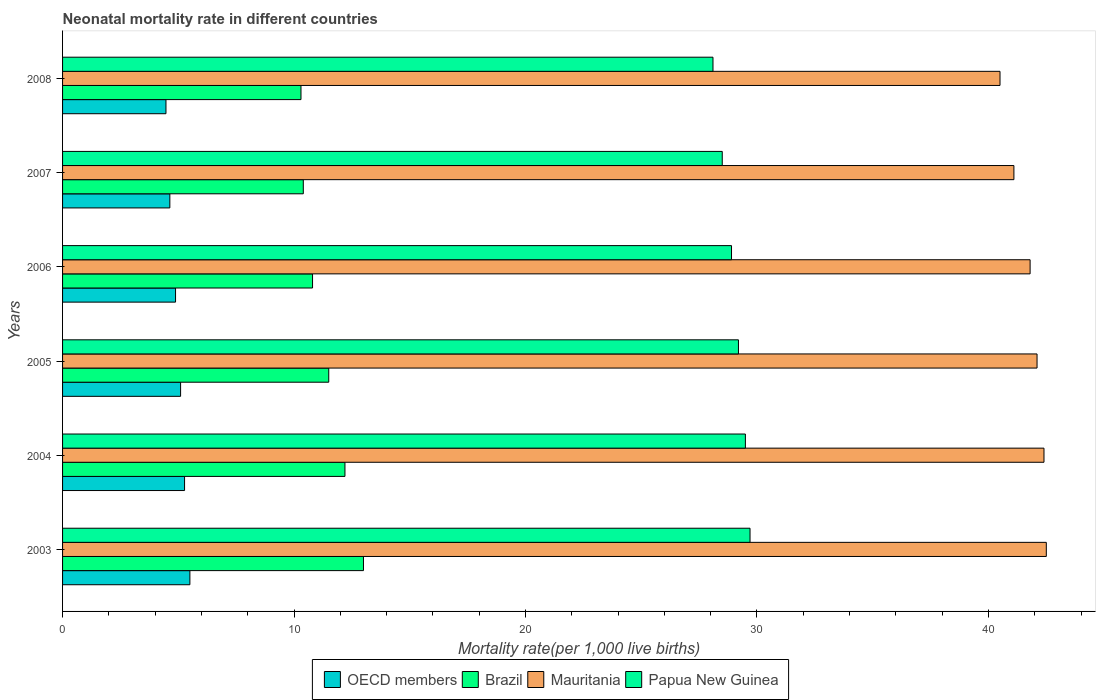Are the number of bars per tick equal to the number of legend labels?
Your answer should be very brief. Yes. Are the number of bars on each tick of the Y-axis equal?
Ensure brevity in your answer.  Yes. How many bars are there on the 3rd tick from the top?
Provide a succinct answer. 4. In how many cases, is the number of bars for a given year not equal to the number of legend labels?
Keep it short and to the point. 0. What is the neonatal mortality rate in Brazil in 2008?
Give a very brief answer. 10.3. Across all years, what is the maximum neonatal mortality rate in Papua New Guinea?
Ensure brevity in your answer.  29.7. Across all years, what is the minimum neonatal mortality rate in Papua New Guinea?
Give a very brief answer. 28.1. In which year was the neonatal mortality rate in Papua New Guinea minimum?
Make the answer very short. 2008. What is the total neonatal mortality rate in Papua New Guinea in the graph?
Your answer should be compact. 173.9. What is the difference between the neonatal mortality rate in OECD members in 2003 and that in 2008?
Your answer should be compact. 1.03. What is the difference between the neonatal mortality rate in OECD members in 2006 and the neonatal mortality rate in Brazil in 2005?
Make the answer very short. -6.62. What is the average neonatal mortality rate in OECD members per year?
Your answer should be compact. 4.98. In the year 2007, what is the difference between the neonatal mortality rate in Brazil and neonatal mortality rate in Papua New Guinea?
Give a very brief answer. -18.1. In how many years, is the neonatal mortality rate in Mauritania greater than 14 ?
Keep it short and to the point. 6. What is the ratio of the neonatal mortality rate in OECD members in 2003 to that in 2004?
Provide a succinct answer. 1.04. Is the neonatal mortality rate in Brazil in 2003 less than that in 2007?
Your answer should be very brief. No. What is the difference between the highest and the second highest neonatal mortality rate in Papua New Guinea?
Your response must be concise. 0.2. Is it the case that in every year, the sum of the neonatal mortality rate in OECD members and neonatal mortality rate in Mauritania is greater than the sum of neonatal mortality rate in Brazil and neonatal mortality rate in Papua New Guinea?
Provide a succinct answer. No. What does the 3rd bar from the bottom in 2004 represents?
Provide a short and direct response. Mauritania. What is the difference between two consecutive major ticks on the X-axis?
Your answer should be compact. 10. Are the values on the major ticks of X-axis written in scientific E-notation?
Your answer should be compact. No. Does the graph contain any zero values?
Offer a very short reply. No. Where does the legend appear in the graph?
Offer a terse response. Bottom center. How are the legend labels stacked?
Offer a terse response. Horizontal. What is the title of the graph?
Keep it short and to the point. Neonatal mortality rate in different countries. Does "Somalia" appear as one of the legend labels in the graph?
Offer a very short reply. No. What is the label or title of the X-axis?
Provide a short and direct response. Mortality rate(per 1,0 live births). What is the label or title of the Y-axis?
Make the answer very short. Years. What is the Mortality rate(per 1,000 live births) in OECD members in 2003?
Your answer should be compact. 5.5. What is the Mortality rate(per 1,000 live births) in Mauritania in 2003?
Offer a terse response. 42.5. What is the Mortality rate(per 1,000 live births) in Papua New Guinea in 2003?
Offer a terse response. 29.7. What is the Mortality rate(per 1,000 live births) in OECD members in 2004?
Offer a very short reply. 5.27. What is the Mortality rate(per 1,000 live births) of Brazil in 2004?
Ensure brevity in your answer.  12.2. What is the Mortality rate(per 1,000 live births) of Mauritania in 2004?
Your response must be concise. 42.4. What is the Mortality rate(per 1,000 live births) of Papua New Guinea in 2004?
Your response must be concise. 29.5. What is the Mortality rate(per 1,000 live births) in OECD members in 2005?
Ensure brevity in your answer.  5.1. What is the Mortality rate(per 1,000 live births) of Mauritania in 2005?
Ensure brevity in your answer.  42.1. What is the Mortality rate(per 1,000 live births) of Papua New Guinea in 2005?
Offer a terse response. 29.2. What is the Mortality rate(per 1,000 live births) in OECD members in 2006?
Provide a short and direct response. 4.88. What is the Mortality rate(per 1,000 live births) in Mauritania in 2006?
Your answer should be very brief. 41.8. What is the Mortality rate(per 1,000 live births) in Papua New Guinea in 2006?
Ensure brevity in your answer.  28.9. What is the Mortality rate(per 1,000 live births) of OECD members in 2007?
Your answer should be very brief. 4.63. What is the Mortality rate(per 1,000 live births) in Brazil in 2007?
Keep it short and to the point. 10.4. What is the Mortality rate(per 1,000 live births) of Mauritania in 2007?
Your answer should be very brief. 41.1. What is the Mortality rate(per 1,000 live births) of Papua New Guinea in 2007?
Make the answer very short. 28.5. What is the Mortality rate(per 1,000 live births) in OECD members in 2008?
Keep it short and to the point. 4.47. What is the Mortality rate(per 1,000 live births) of Mauritania in 2008?
Make the answer very short. 40.5. What is the Mortality rate(per 1,000 live births) of Papua New Guinea in 2008?
Provide a short and direct response. 28.1. Across all years, what is the maximum Mortality rate(per 1,000 live births) of OECD members?
Give a very brief answer. 5.5. Across all years, what is the maximum Mortality rate(per 1,000 live births) of Mauritania?
Your answer should be compact. 42.5. Across all years, what is the maximum Mortality rate(per 1,000 live births) in Papua New Guinea?
Ensure brevity in your answer.  29.7. Across all years, what is the minimum Mortality rate(per 1,000 live births) in OECD members?
Your response must be concise. 4.47. Across all years, what is the minimum Mortality rate(per 1,000 live births) in Mauritania?
Ensure brevity in your answer.  40.5. Across all years, what is the minimum Mortality rate(per 1,000 live births) in Papua New Guinea?
Offer a very short reply. 28.1. What is the total Mortality rate(per 1,000 live births) of OECD members in the graph?
Your answer should be very brief. 29.85. What is the total Mortality rate(per 1,000 live births) of Brazil in the graph?
Provide a succinct answer. 68.2. What is the total Mortality rate(per 1,000 live births) in Mauritania in the graph?
Your answer should be compact. 250.4. What is the total Mortality rate(per 1,000 live births) in Papua New Guinea in the graph?
Ensure brevity in your answer.  173.9. What is the difference between the Mortality rate(per 1,000 live births) in OECD members in 2003 and that in 2004?
Provide a succinct answer. 0.23. What is the difference between the Mortality rate(per 1,000 live births) in Mauritania in 2003 and that in 2004?
Your answer should be compact. 0.1. What is the difference between the Mortality rate(per 1,000 live births) of OECD members in 2003 and that in 2005?
Your response must be concise. 0.4. What is the difference between the Mortality rate(per 1,000 live births) of OECD members in 2003 and that in 2006?
Keep it short and to the point. 0.62. What is the difference between the Mortality rate(per 1,000 live births) in Brazil in 2003 and that in 2006?
Offer a terse response. 2.2. What is the difference between the Mortality rate(per 1,000 live births) of Mauritania in 2003 and that in 2006?
Give a very brief answer. 0.7. What is the difference between the Mortality rate(per 1,000 live births) of OECD members in 2003 and that in 2007?
Your response must be concise. 0.87. What is the difference between the Mortality rate(per 1,000 live births) of OECD members in 2003 and that in 2008?
Provide a succinct answer. 1.03. What is the difference between the Mortality rate(per 1,000 live births) of Mauritania in 2003 and that in 2008?
Keep it short and to the point. 2. What is the difference between the Mortality rate(per 1,000 live births) of Papua New Guinea in 2003 and that in 2008?
Provide a short and direct response. 1.6. What is the difference between the Mortality rate(per 1,000 live births) of OECD members in 2004 and that in 2005?
Provide a succinct answer. 0.17. What is the difference between the Mortality rate(per 1,000 live births) in Brazil in 2004 and that in 2005?
Provide a short and direct response. 0.7. What is the difference between the Mortality rate(per 1,000 live births) of Mauritania in 2004 and that in 2005?
Provide a short and direct response. 0.3. What is the difference between the Mortality rate(per 1,000 live births) in OECD members in 2004 and that in 2006?
Provide a succinct answer. 0.39. What is the difference between the Mortality rate(per 1,000 live births) of Brazil in 2004 and that in 2006?
Keep it short and to the point. 1.4. What is the difference between the Mortality rate(per 1,000 live births) of OECD members in 2004 and that in 2007?
Your answer should be compact. 0.64. What is the difference between the Mortality rate(per 1,000 live births) in Brazil in 2004 and that in 2007?
Your answer should be compact. 1.8. What is the difference between the Mortality rate(per 1,000 live births) in Papua New Guinea in 2004 and that in 2007?
Your answer should be very brief. 1. What is the difference between the Mortality rate(per 1,000 live births) of OECD members in 2004 and that in 2008?
Your response must be concise. 0.8. What is the difference between the Mortality rate(per 1,000 live births) of OECD members in 2005 and that in 2006?
Ensure brevity in your answer.  0.22. What is the difference between the Mortality rate(per 1,000 live births) of Brazil in 2005 and that in 2006?
Give a very brief answer. 0.7. What is the difference between the Mortality rate(per 1,000 live births) of OECD members in 2005 and that in 2007?
Your answer should be compact. 0.46. What is the difference between the Mortality rate(per 1,000 live births) of Brazil in 2005 and that in 2007?
Your response must be concise. 1.1. What is the difference between the Mortality rate(per 1,000 live births) in Mauritania in 2005 and that in 2007?
Offer a very short reply. 1. What is the difference between the Mortality rate(per 1,000 live births) of Papua New Guinea in 2005 and that in 2007?
Offer a terse response. 0.7. What is the difference between the Mortality rate(per 1,000 live births) of OECD members in 2005 and that in 2008?
Give a very brief answer. 0.63. What is the difference between the Mortality rate(per 1,000 live births) in Brazil in 2005 and that in 2008?
Ensure brevity in your answer.  1.2. What is the difference between the Mortality rate(per 1,000 live births) of Mauritania in 2005 and that in 2008?
Offer a terse response. 1.6. What is the difference between the Mortality rate(per 1,000 live births) of OECD members in 2006 and that in 2007?
Your response must be concise. 0.25. What is the difference between the Mortality rate(per 1,000 live births) of Mauritania in 2006 and that in 2007?
Provide a short and direct response. 0.7. What is the difference between the Mortality rate(per 1,000 live births) in OECD members in 2006 and that in 2008?
Keep it short and to the point. 0.41. What is the difference between the Mortality rate(per 1,000 live births) of Mauritania in 2006 and that in 2008?
Make the answer very short. 1.3. What is the difference between the Mortality rate(per 1,000 live births) in OECD members in 2007 and that in 2008?
Give a very brief answer. 0.17. What is the difference between the Mortality rate(per 1,000 live births) of Mauritania in 2007 and that in 2008?
Your response must be concise. 0.6. What is the difference between the Mortality rate(per 1,000 live births) in OECD members in 2003 and the Mortality rate(per 1,000 live births) in Brazil in 2004?
Provide a succinct answer. -6.7. What is the difference between the Mortality rate(per 1,000 live births) of OECD members in 2003 and the Mortality rate(per 1,000 live births) of Mauritania in 2004?
Your response must be concise. -36.9. What is the difference between the Mortality rate(per 1,000 live births) in OECD members in 2003 and the Mortality rate(per 1,000 live births) in Papua New Guinea in 2004?
Provide a short and direct response. -24. What is the difference between the Mortality rate(per 1,000 live births) in Brazil in 2003 and the Mortality rate(per 1,000 live births) in Mauritania in 2004?
Give a very brief answer. -29.4. What is the difference between the Mortality rate(per 1,000 live births) in Brazil in 2003 and the Mortality rate(per 1,000 live births) in Papua New Guinea in 2004?
Your answer should be very brief. -16.5. What is the difference between the Mortality rate(per 1,000 live births) of OECD members in 2003 and the Mortality rate(per 1,000 live births) of Brazil in 2005?
Make the answer very short. -6. What is the difference between the Mortality rate(per 1,000 live births) in OECD members in 2003 and the Mortality rate(per 1,000 live births) in Mauritania in 2005?
Make the answer very short. -36.6. What is the difference between the Mortality rate(per 1,000 live births) in OECD members in 2003 and the Mortality rate(per 1,000 live births) in Papua New Guinea in 2005?
Provide a short and direct response. -23.7. What is the difference between the Mortality rate(per 1,000 live births) in Brazil in 2003 and the Mortality rate(per 1,000 live births) in Mauritania in 2005?
Offer a terse response. -29.1. What is the difference between the Mortality rate(per 1,000 live births) of Brazil in 2003 and the Mortality rate(per 1,000 live births) of Papua New Guinea in 2005?
Give a very brief answer. -16.2. What is the difference between the Mortality rate(per 1,000 live births) in OECD members in 2003 and the Mortality rate(per 1,000 live births) in Brazil in 2006?
Make the answer very short. -5.3. What is the difference between the Mortality rate(per 1,000 live births) in OECD members in 2003 and the Mortality rate(per 1,000 live births) in Mauritania in 2006?
Provide a succinct answer. -36.3. What is the difference between the Mortality rate(per 1,000 live births) of OECD members in 2003 and the Mortality rate(per 1,000 live births) of Papua New Guinea in 2006?
Keep it short and to the point. -23.4. What is the difference between the Mortality rate(per 1,000 live births) of Brazil in 2003 and the Mortality rate(per 1,000 live births) of Mauritania in 2006?
Your response must be concise. -28.8. What is the difference between the Mortality rate(per 1,000 live births) in Brazil in 2003 and the Mortality rate(per 1,000 live births) in Papua New Guinea in 2006?
Keep it short and to the point. -15.9. What is the difference between the Mortality rate(per 1,000 live births) in OECD members in 2003 and the Mortality rate(per 1,000 live births) in Brazil in 2007?
Offer a terse response. -4.9. What is the difference between the Mortality rate(per 1,000 live births) of OECD members in 2003 and the Mortality rate(per 1,000 live births) of Mauritania in 2007?
Your answer should be compact. -35.6. What is the difference between the Mortality rate(per 1,000 live births) in OECD members in 2003 and the Mortality rate(per 1,000 live births) in Papua New Guinea in 2007?
Keep it short and to the point. -23. What is the difference between the Mortality rate(per 1,000 live births) in Brazil in 2003 and the Mortality rate(per 1,000 live births) in Mauritania in 2007?
Keep it short and to the point. -28.1. What is the difference between the Mortality rate(per 1,000 live births) of Brazil in 2003 and the Mortality rate(per 1,000 live births) of Papua New Guinea in 2007?
Keep it short and to the point. -15.5. What is the difference between the Mortality rate(per 1,000 live births) of OECD members in 2003 and the Mortality rate(per 1,000 live births) of Brazil in 2008?
Your answer should be very brief. -4.8. What is the difference between the Mortality rate(per 1,000 live births) of OECD members in 2003 and the Mortality rate(per 1,000 live births) of Mauritania in 2008?
Offer a very short reply. -35. What is the difference between the Mortality rate(per 1,000 live births) in OECD members in 2003 and the Mortality rate(per 1,000 live births) in Papua New Guinea in 2008?
Ensure brevity in your answer.  -22.6. What is the difference between the Mortality rate(per 1,000 live births) of Brazil in 2003 and the Mortality rate(per 1,000 live births) of Mauritania in 2008?
Offer a very short reply. -27.5. What is the difference between the Mortality rate(per 1,000 live births) of Brazil in 2003 and the Mortality rate(per 1,000 live births) of Papua New Guinea in 2008?
Provide a short and direct response. -15.1. What is the difference between the Mortality rate(per 1,000 live births) in OECD members in 2004 and the Mortality rate(per 1,000 live births) in Brazil in 2005?
Your answer should be compact. -6.23. What is the difference between the Mortality rate(per 1,000 live births) of OECD members in 2004 and the Mortality rate(per 1,000 live births) of Mauritania in 2005?
Give a very brief answer. -36.83. What is the difference between the Mortality rate(per 1,000 live births) of OECD members in 2004 and the Mortality rate(per 1,000 live births) of Papua New Guinea in 2005?
Offer a terse response. -23.93. What is the difference between the Mortality rate(per 1,000 live births) in Brazil in 2004 and the Mortality rate(per 1,000 live births) in Mauritania in 2005?
Your response must be concise. -29.9. What is the difference between the Mortality rate(per 1,000 live births) in Brazil in 2004 and the Mortality rate(per 1,000 live births) in Papua New Guinea in 2005?
Give a very brief answer. -17. What is the difference between the Mortality rate(per 1,000 live births) in Mauritania in 2004 and the Mortality rate(per 1,000 live births) in Papua New Guinea in 2005?
Offer a very short reply. 13.2. What is the difference between the Mortality rate(per 1,000 live births) of OECD members in 2004 and the Mortality rate(per 1,000 live births) of Brazil in 2006?
Provide a succinct answer. -5.53. What is the difference between the Mortality rate(per 1,000 live births) in OECD members in 2004 and the Mortality rate(per 1,000 live births) in Mauritania in 2006?
Make the answer very short. -36.53. What is the difference between the Mortality rate(per 1,000 live births) of OECD members in 2004 and the Mortality rate(per 1,000 live births) of Papua New Guinea in 2006?
Offer a very short reply. -23.63. What is the difference between the Mortality rate(per 1,000 live births) in Brazil in 2004 and the Mortality rate(per 1,000 live births) in Mauritania in 2006?
Keep it short and to the point. -29.6. What is the difference between the Mortality rate(per 1,000 live births) of Brazil in 2004 and the Mortality rate(per 1,000 live births) of Papua New Guinea in 2006?
Your response must be concise. -16.7. What is the difference between the Mortality rate(per 1,000 live births) in Mauritania in 2004 and the Mortality rate(per 1,000 live births) in Papua New Guinea in 2006?
Your response must be concise. 13.5. What is the difference between the Mortality rate(per 1,000 live births) in OECD members in 2004 and the Mortality rate(per 1,000 live births) in Brazil in 2007?
Offer a terse response. -5.13. What is the difference between the Mortality rate(per 1,000 live births) of OECD members in 2004 and the Mortality rate(per 1,000 live births) of Mauritania in 2007?
Your answer should be compact. -35.83. What is the difference between the Mortality rate(per 1,000 live births) in OECD members in 2004 and the Mortality rate(per 1,000 live births) in Papua New Guinea in 2007?
Keep it short and to the point. -23.23. What is the difference between the Mortality rate(per 1,000 live births) in Brazil in 2004 and the Mortality rate(per 1,000 live births) in Mauritania in 2007?
Provide a short and direct response. -28.9. What is the difference between the Mortality rate(per 1,000 live births) in Brazil in 2004 and the Mortality rate(per 1,000 live births) in Papua New Guinea in 2007?
Your answer should be compact. -16.3. What is the difference between the Mortality rate(per 1,000 live births) in Mauritania in 2004 and the Mortality rate(per 1,000 live births) in Papua New Guinea in 2007?
Ensure brevity in your answer.  13.9. What is the difference between the Mortality rate(per 1,000 live births) of OECD members in 2004 and the Mortality rate(per 1,000 live births) of Brazil in 2008?
Provide a succinct answer. -5.03. What is the difference between the Mortality rate(per 1,000 live births) of OECD members in 2004 and the Mortality rate(per 1,000 live births) of Mauritania in 2008?
Offer a terse response. -35.23. What is the difference between the Mortality rate(per 1,000 live births) in OECD members in 2004 and the Mortality rate(per 1,000 live births) in Papua New Guinea in 2008?
Keep it short and to the point. -22.83. What is the difference between the Mortality rate(per 1,000 live births) of Brazil in 2004 and the Mortality rate(per 1,000 live births) of Mauritania in 2008?
Give a very brief answer. -28.3. What is the difference between the Mortality rate(per 1,000 live births) of Brazil in 2004 and the Mortality rate(per 1,000 live births) of Papua New Guinea in 2008?
Offer a very short reply. -15.9. What is the difference between the Mortality rate(per 1,000 live births) in Mauritania in 2004 and the Mortality rate(per 1,000 live births) in Papua New Guinea in 2008?
Provide a succinct answer. 14.3. What is the difference between the Mortality rate(per 1,000 live births) in OECD members in 2005 and the Mortality rate(per 1,000 live births) in Brazil in 2006?
Your response must be concise. -5.7. What is the difference between the Mortality rate(per 1,000 live births) of OECD members in 2005 and the Mortality rate(per 1,000 live births) of Mauritania in 2006?
Provide a short and direct response. -36.7. What is the difference between the Mortality rate(per 1,000 live births) in OECD members in 2005 and the Mortality rate(per 1,000 live births) in Papua New Guinea in 2006?
Your answer should be compact. -23.8. What is the difference between the Mortality rate(per 1,000 live births) in Brazil in 2005 and the Mortality rate(per 1,000 live births) in Mauritania in 2006?
Your response must be concise. -30.3. What is the difference between the Mortality rate(per 1,000 live births) of Brazil in 2005 and the Mortality rate(per 1,000 live births) of Papua New Guinea in 2006?
Offer a very short reply. -17.4. What is the difference between the Mortality rate(per 1,000 live births) in Mauritania in 2005 and the Mortality rate(per 1,000 live births) in Papua New Guinea in 2006?
Ensure brevity in your answer.  13.2. What is the difference between the Mortality rate(per 1,000 live births) of OECD members in 2005 and the Mortality rate(per 1,000 live births) of Brazil in 2007?
Make the answer very short. -5.3. What is the difference between the Mortality rate(per 1,000 live births) of OECD members in 2005 and the Mortality rate(per 1,000 live births) of Mauritania in 2007?
Offer a terse response. -36. What is the difference between the Mortality rate(per 1,000 live births) in OECD members in 2005 and the Mortality rate(per 1,000 live births) in Papua New Guinea in 2007?
Your response must be concise. -23.4. What is the difference between the Mortality rate(per 1,000 live births) in Brazil in 2005 and the Mortality rate(per 1,000 live births) in Mauritania in 2007?
Your answer should be compact. -29.6. What is the difference between the Mortality rate(per 1,000 live births) in Brazil in 2005 and the Mortality rate(per 1,000 live births) in Papua New Guinea in 2007?
Give a very brief answer. -17. What is the difference between the Mortality rate(per 1,000 live births) of Mauritania in 2005 and the Mortality rate(per 1,000 live births) of Papua New Guinea in 2007?
Provide a succinct answer. 13.6. What is the difference between the Mortality rate(per 1,000 live births) of OECD members in 2005 and the Mortality rate(per 1,000 live births) of Brazil in 2008?
Make the answer very short. -5.2. What is the difference between the Mortality rate(per 1,000 live births) of OECD members in 2005 and the Mortality rate(per 1,000 live births) of Mauritania in 2008?
Ensure brevity in your answer.  -35.4. What is the difference between the Mortality rate(per 1,000 live births) of OECD members in 2005 and the Mortality rate(per 1,000 live births) of Papua New Guinea in 2008?
Your answer should be very brief. -23. What is the difference between the Mortality rate(per 1,000 live births) of Brazil in 2005 and the Mortality rate(per 1,000 live births) of Papua New Guinea in 2008?
Provide a succinct answer. -16.6. What is the difference between the Mortality rate(per 1,000 live births) in OECD members in 2006 and the Mortality rate(per 1,000 live births) in Brazil in 2007?
Make the answer very short. -5.52. What is the difference between the Mortality rate(per 1,000 live births) in OECD members in 2006 and the Mortality rate(per 1,000 live births) in Mauritania in 2007?
Offer a terse response. -36.22. What is the difference between the Mortality rate(per 1,000 live births) in OECD members in 2006 and the Mortality rate(per 1,000 live births) in Papua New Guinea in 2007?
Offer a terse response. -23.62. What is the difference between the Mortality rate(per 1,000 live births) of Brazil in 2006 and the Mortality rate(per 1,000 live births) of Mauritania in 2007?
Make the answer very short. -30.3. What is the difference between the Mortality rate(per 1,000 live births) of Brazil in 2006 and the Mortality rate(per 1,000 live births) of Papua New Guinea in 2007?
Your answer should be very brief. -17.7. What is the difference between the Mortality rate(per 1,000 live births) of OECD members in 2006 and the Mortality rate(per 1,000 live births) of Brazil in 2008?
Offer a terse response. -5.42. What is the difference between the Mortality rate(per 1,000 live births) in OECD members in 2006 and the Mortality rate(per 1,000 live births) in Mauritania in 2008?
Offer a terse response. -35.62. What is the difference between the Mortality rate(per 1,000 live births) in OECD members in 2006 and the Mortality rate(per 1,000 live births) in Papua New Guinea in 2008?
Provide a short and direct response. -23.22. What is the difference between the Mortality rate(per 1,000 live births) in Brazil in 2006 and the Mortality rate(per 1,000 live births) in Mauritania in 2008?
Keep it short and to the point. -29.7. What is the difference between the Mortality rate(per 1,000 live births) of Brazil in 2006 and the Mortality rate(per 1,000 live births) of Papua New Guinea in 2008?
Provide a succinct answer. -17.3. What is the difference between the Mortality rate(per 1,000 live births) of Mauritania in 2006 and the Mortality rate(per 1,000 live births) of Papua New Guinea in 2008?
Offer a terse response. 13.7. What is the difference between the Mortality rate(per 1,000 live births) in OECD members in 2007 and the Mortality rate(per 1,000 live births) in Brazil in 2008?
Keep it short and to the point. -5.67. What is the difference between the Mortality rate(per 1,000 live births) of OECD members in 2007 and the Mortality rate(per 1,000 live births) of Mauritania in 2008?
Offer a very short reply. -35.87. What is the difference between the Mortality rate(per 1,000 live births) of OECD members in 2007 and the Mortality rate(per 1,000 live births) of Papua New Guinea in 2008?
Your response must be concise. -23.47. What is the difference between the Mortality rate(per 1,000 live births) of Brazil in 2007 and the Mortality rate(per 1,000 live births) of Mauritania in 2008?
Provide a succinct answer. -30.1. What is the difference between the Mortality rate(per 1,000 live births) in Brazil in 2007 and the Mortality rate(per 1,000 live births) in Papua New Guinea in 2008?
Keep it short and to the point. -17.7. What is the average Mortality rate(per 1,000 live births) of OECD members per year?
Ensure brevity in your answer.  4.98. What is the average Mortality rate(per 1,000 live births) of Brazil per year?
Give a very brief answer. 11.37. What is the average Mortality rate(per 1,000 live births) in Mauritania per year?
Provide a short and direct response. 41.73. What is the average Mortality rate(per 1,000 live births) in Papua New Guinea per year?
Ensure brevity in your answer.  28.98. In the year 2003, what is the difference between the Mortality rate(per 1,000 live births) of OECD members and Mortality rate(per 1,000 live births) of Brazil?
Give a very brief answer. -7.5. In the year 2003, what is the difference between the Mortality rate(per 1,000 live births) of OECD members and Mortality rate(per 1,000 live births) of Mauritania?
Keep it short and to the point. -37. In the year 2003, what is the difference between the Mortality rate(per 1,000 live births) in OECD members and Mortality rate(per 1,000 live births) in Papua New Guinea?
Provide a short and direct response. -24.2. In the year 2003, what is the difference between the Mortality rate(per 1,000 live births) in Brazil and Mortality rate(per 1,000 live births) in Mauritania?
Ensure brevity in your answer.  -29.5. In the year 2003, what is the difference between the Mortality rate(per 1,000 live births) of Brazil and Mortality rate(per 1,000 live births) of Papua New Guinea?
Offer a terse response. -16.7. In the year 2003, what is the difference between the Mortality rate(per 1,000 live births) of Mauritania and Mortality rate(per 1,000 live births) of Papua New Guinea?
Your answer should be compact. 12.8. In the year 2004, what is the difference between the Mortality rate(per 1,000 live births) of OECD members and Mortality rate(per 1,000 live births) of Brazil?
Give a very brief answer. -6.93. In the year 2004, what is the difference between the Mortality rate(per 1,000 live births) in OECD members and Mortality rate(per 1,000 live births) in Mauritania?
Offer a terse response. -37.13. In the year 2004, what is the difference between the Mortality rate(per 1,000 live births) of OECD members and Mortality rate(per 1,000 live births) of Papua New Guinea?
Your answer should be very brief. -24.23. In the year 2004, what is the difference between the Mortality rate(per 1,000 live births) of Brazil and Mortality rate(per 1,000 live births) of Mauritania?
Your response must be concise. -30.2. In the year 2004, what is the difference between the Mortality rate(per 1,000 live births) of Brazil and Mortality rate(per 1,000 live births) of Papua New Guinea?
Make the answer very short. -17.3. In the year 2005, what is the difference between the Mortality rate(per 1,000 live births) in OECD members and Mortality rate(per 1,000 live births) in Brazil?
Offer a very short reply. -6.4. In the year 2005, what is the difference between the Mortality rate(per 1,000 live births) in OECD members and Mortality rate(per 1,000 live births) in Mauritania?
Provide a short and direct response. -37. In the year 2005, what is the difference between the Mortality rate(per 1,000 live births) in OECD members and Mortality rate(per 1,000 live births) in Papua New Guinea?
Offer a terse response. -24.1. In the year 2005, what is the difference between the Mortality rate(per 1,000 live births) in Brazil and Mortality rate(per 1,000 live births) in Mauritania?
Provide a succinct answer. -30.6. In the year 2005, what is the difference between the Mortality rate(per 1,000 live births) of Brazil and Mortality rate(per 1,000 live births) of Papua New Guinea?
Your response must be concise. -17.7. In the year 2005, what is the difference between the Mortality rate(per 1,000 live births) in Mauritania and Mortality rate(per 1,000 live births) in Papua New Guinea?
Give a very brief answer. 12.9. In the year 2006, what is the difference between the Mortality rate(per 1,000 live births) of OECD members and Mortality rate(per 1,000 live births) of Brazil?
Provide a succinct answer. -5.92. In the year 2006, what is the difference between the Mortality rate(per 1,000 live births) of OECD members and Mortality rate(per 1,000 live births) of Mauritania?
Offer a terse response. -36.92. In the year 2006, what is the difference between the Mortality rate(per 1,000 live births) in OECD members and Mortality rate(per 1,000 live births) in Papua New Guinea?
Provide a short and direct response. -24.02. In the year 2006, what is the difference between the Mortality rate(per 1,000 live births) of Brazil and Mortality rate(per 1,000 live births) of Mauritania?
Provide a short and direct response. -31. In the year 2006, what is the difference between the Mortality rate(per 1,000 live births) in Brazil and Mortality rate(per 1,000 live births) in Papua New Guinea?
Keep it short and to the point. -18.1. In the year 2007, what is the difference between the Mortality rate(per 1,000 live births) of OECD members and Mortality rate(per 1,000 live births) of Brazil?
Your answer should be compact. -5.77. In the year 2007, what is the difference between the Mortality rate(per 1,000 live births) of OECD members and Mortality rate(per 1,000 live births) of Mauritania?
Provide a short and direct response. -36.47. In the year 2007, what is the difference between the Mortality rate(per 1,000 live births) of OECD members and Mortality rate(per 1,000 live births) of Papua New Guinea?
Your answer should be compact. -23.87. In the year 2007, what is the difference between the Mortality rate(per 1,000 live births) of Brazil and Mortality rate(per 1,000 live births) of Mauritania?
Ensure brevity in your answer.  -30.7. In the year 2007, what is the difference between the Mortality rate(per 1,000 live births) in Brazil and Mortality rate(per 1,000 live births) in Papua New Guinea?
Ensure brevity in your answer.  -18.1. In the year 2007, what is the difference between the Mortality rate(per 1,000 live births) in Mauritania and Mortality rate(per 1,000 live births) in Papua New Guinea?
Provide a succinct answer. 12.6. In the year 2008, what is the difference between the Mortality rate(per 1,000 live births) in OECD members and Mortality rate(per 1,000 live births) in Brazil?
Provide a short and direct response. -5.83. In the year 2008, what is the difference between the Mortality rate(per 1,000 live births) in OECD members and Mortality rate(per 1,000 live births) in Mauritania?
Ensure brevity in your answer.  -36.03. In the year 2008, what is the difference between the Mortality rate(per 1,000 live births) in OECD members and Mortality rate(per 1,000 live births) in Papua New Guinea?
Keep it short and to the point. -23.63. In the year 2008, what is the difference between the Mortality rate(per 1,000 live births) of Brazil and Mortality rate(per 1,000 live births) of Mauritania?
Your response must be concise. -30.2. In the year 2008, what is the difference between the Mortality rate(per 1,000 live births) in Brazil and Mortality rate(per 1,000 live births) in Papua New Guinea?
Keep it short and to the point. -17.8. What is the ratio of the Mortality rate(per 1,000 live births) in OECD members in 2003 to that in 2004?
Make the answer very short. 1.04. What is the ratio of the Mortality rate(per 1,000 live births) of Brazil in 2003 to that in 2004?
Keep it short and to the point. 1.07. What is the ratio of the Mortality rate(per 1,000 live births) in Papua New Guinea in 2003 to that in 2004?
Provide a short and direct response. 1.01. What is the ratio of the Mortality rate(per 1,000 live births) of OECD members in 2003 to that in 2005?
Provide a short and direct response. 1.08. What is the ratio of the Mortality rate(per 1,000 live births) in Brazil in 2003 to that in 2005?
Offer a very short reply. 1.13. What is the ratio of the Mortality rate(per 1,000 live births) of Mauritania in 2003 to that in 2005?
Provide a short and direct response. 1.01. What is the ratio of the Mortality rate(per 1,000 live births) in Papua New Guinea in 2003 to that in 2005?
Provide a short and direct response. 1.02. What is the ratio of the Mortality rate(per 1,000 live births) of OECD members in 2003 to that in 2006?
Your answer should be very brief. 1.13. What is the ratio of the Mortality rate(per 1,000 live births) in Brazil in 2003 to that in 2006?
Your response must be concise. 1.2. What is the ratio of the Mortality rate(per 1,000 live births) of Mauritania in 2003 to that in 2006?
Provide a short and direct response. 1.02. What is the ratio of the Mortality rate(per 1,000 live births) in Papua New Guinea in 2003 to that in 2006?
Keep it short and to the point. 1.03. What is the ratio of the Mortality rate(per 1,000 live births) of OECD members in 2003 to that in 2007?
Offer a terse response. 1.19. What is the ratio of the Mortality rate(per 1,000 live births) of Brazil in 2003 to that in 2007?
Provide a short and direct response. 1.25. What is the ratio of the Mortality rate(per 1,000 live births) in Mauritania in 2003 to that in 2007?
Offer a terse response. 1.03. What is the ratio of the Mortality rate(per 1,000 live births) of Papua New Guinea in 2003 to that in 2007?
Your answer should be compact. 1.04. What is the ratio of the Mortality rate(per 1,000 live births) in OECD members in 2003 to that in 2008?
Your response must be concise. 1.23. What is the ratio of the Mortality rate(per 1,000 live births) of Brazil in 2003 to that in 2008?
Your answer should be compact. 1.26. What is the ratio of the Mortality rate(per 1,000 live births) of Mauritania in 2003 to that in 2008?
Make the answer very short. 1.05. What is the ratio of the Mortality rate(per 1,000 live births) in Papua New Guinea in 2003 to that in 2008?
Keep it short and to the point. 1.06. What is the ratio of the Mortality rate(per 1,000 live births) of OECD members in 2004 to that in 2005?
Give a very brief answer. 1.03. What is the ratio of the Mortality rate(per 1,000 live births) of Brazil in 2004 to that in 2005?
Your answer should be very brief. 1.06. What is the ratio of the Mortality rate(per 1,000 live births) in Mauritania in 2004 to that in 2005?
Provide a succinct answer. 1.01. What is the ratio of the Mortality rate(per 1,000 live births) in Papua New Guinea in 2004 to that in 2005?
Give a very brief answer. 1.01. What is the ratio of the Mortality rate(per 1,000 live births) of OECD members in 2004 to that in 2006?
Your answer should be compact. 1.08. What is the ratio of the Mortality rate(per 1,000 live births) of Brazil in 2004 to that in 2006?
Give a very brief answer. 1.13. What is the ratio of the Mortality rate(per 1,000 live births) in Mauritania in 2004 to that in 2006?
Your answer should be compact. 1.01. What is the ratio of the Mortality rate(per 1,000 live births) in Papua New Guinea in 2004 to that in 2006?
Your answer should be very brief. 1.02. What is the ratio of the Mortality rate(per 1,000 live births) in OECD members in 2004 to that in 2007?
Your answer should be compact. 1.14. What is the ratio of the Mortality rate(per 1,000 live births) of Brazil in 2004 to that in 2007?
Offer a terse response. 1.17. What is the ratio of the Mortality rate(per 1,000 live births) of Mauritania in 2004 to that in 2007?
Make the answer very short. 1.03. What is the ratio of the Mortality rate(per 1,000 live births) in Papua New Guinea in 2004 to that in 2007?
Ensure brevity in your answer.  1.04. What is the ratio of the Mortality rate(per 1,000 live births) in OECD members in 2004 to that in 2008?
Your answer should be very brief. 1.18. What is the ratio of the Mortality rate(per 1,000 live births) of Brazil in 2004 to that in 2008?
Provide a short and direct response. 1.18. What is the ratio of the Mortality rate(per 1,000 live births) in Mauritania in 2004 to that in 2008?
Ensure brevity in your answer.  1.05. What is the ratio of the Mortality rate(per 1,000 live births) of Papua New Guinea in 2004 to that in 2008?
Offer a very short reply. 1.05. What is the ratio of the Mortality rate(per 1,000 live births) in OECD members in 2005 to that in 2006?
Your answer should be very brief. 1.04. What is the ratio of the Mortality rate(per 1,000 live births) of Brazil in 2005 to that in 2006?
Give a very brief answer. 1.06. What is the ratio of the Mortality rate(per 1,000 live births) of Papua New Guinea in 2005 to that in 2006?
Provide a short and direct response. 1.01. What is the ratio of the Mortality rate(per 1,000 live births) of OECD members in 2005 to that in 2007?
Your answer should be compact. 1.1. What is the ratio of the Mortality rate(per 1,000 live births) of Brazil in 2005 to that in 2007?
Give a very brief answer. 1.11. What is the ratio of the Mortality rate(per 1,000 live births) of Mauritania in 2005 to that in 2007?
Your answer should be compact. 1.02. What is the ratio of the Mortality rate(per 1,000 live births) in Papua New Guinea in 2005 to that in 2007?
Offer a very short reply. 1.02. What is the ratio of the Mortality rate(per 1,000 live births) of OECD members in 2005 to that in 2008?
Your answer should be compact. 1.14. What is the ratio of the Mortality rate(per 1,000 live births) of Brazil in 2005 to that in 2008?
Your response must be concise. 1.12. What is the ratio of the Mortality rate(per 1,000 live births) in Mauritania in 2005 to that in 2008?
Provide a succinct answer. 1.04. What is the ratio of the Mortality rate(per 1,000 live births) in Papua New Guinea in 2005 to that in 2008?
Your answer should be very brief. 1.04. What is the ratio of the Mortality rate(per 1,000 live births) in OECD members in 2006 to that in 2007?
Give a very brief answer. 1.05. What is the ratio of the Mortality rate(per 1,000 live births) in Brazil in 2006 to that in 2007?
Provide a succinct answer. 1.04. What is the ratio of the Mortality rate(per 1,000 live births) of Papua New Guinea in 2006 to that in 2007?
Offer a terse response. 1.01. What is the ratio of the Mortality rate(per 1,000 live births) of OECD members in 2006 to that in 2008?
Keep it short and to the point. 1.09. What is the ratio of the Mortality rate(per 1,000 live births) of Brazil in 2006 to that in 2008?
Your answer should be very brief. 1.05. What is the ratio of the Mortality rate(per 1,000 live births) of Mauritania in 2006 to that in 2008?
Offer a terse response. 1.03. What is the ratio of the Mortality rate(per 1,000 live births) of Papua New Guinea in 2006 to that in 2008?
Provide a succinct answer. 1.03. What is the ratio of the Mortality rate(per 1,000 live births) of OECD members in 2007 to that in 2008?
Your response must be concise. 1.04. What is the ratio of the Mortality rate(per 1,000 live births) in Brazil in 2007 to that in 2008?
Your answer should be compact. 1.01. What is the ratio of the Mortality rate(per 1,000 live births) in Mauritania in 2007 to that in 2008?
Give a very brief answer. 1.01. What is the ratio of the Mortality rate(per 1,000 live births) in Papua New Guinea in 2007 to that in 2008?
Provide a succinct answer. 1.01. What is the difference between the highest and the second highest Mortality rate(per 1,000 live births) in OECD members?
Offer a terse response. 0.23. What is the difference between the highest and the second highest Mortality rate(per 1,000 live births) of Brazil?
Make the answer very short. 0.8. What is the difference between the highest and the second highest Mortality rate(per 1,000 live births) in Mauritania?
Keep it short and to the point. 0.1. What is the difference between the highest and the second highest Mortality rate(per 1,000 live births) in Papua New Guinea?
Provide a succinct answer. 0.2. What is the difference between the highest and the lowest Mortality rate(per 1,000 live births) in OECD members?
Make the answer very short. 1.03. 